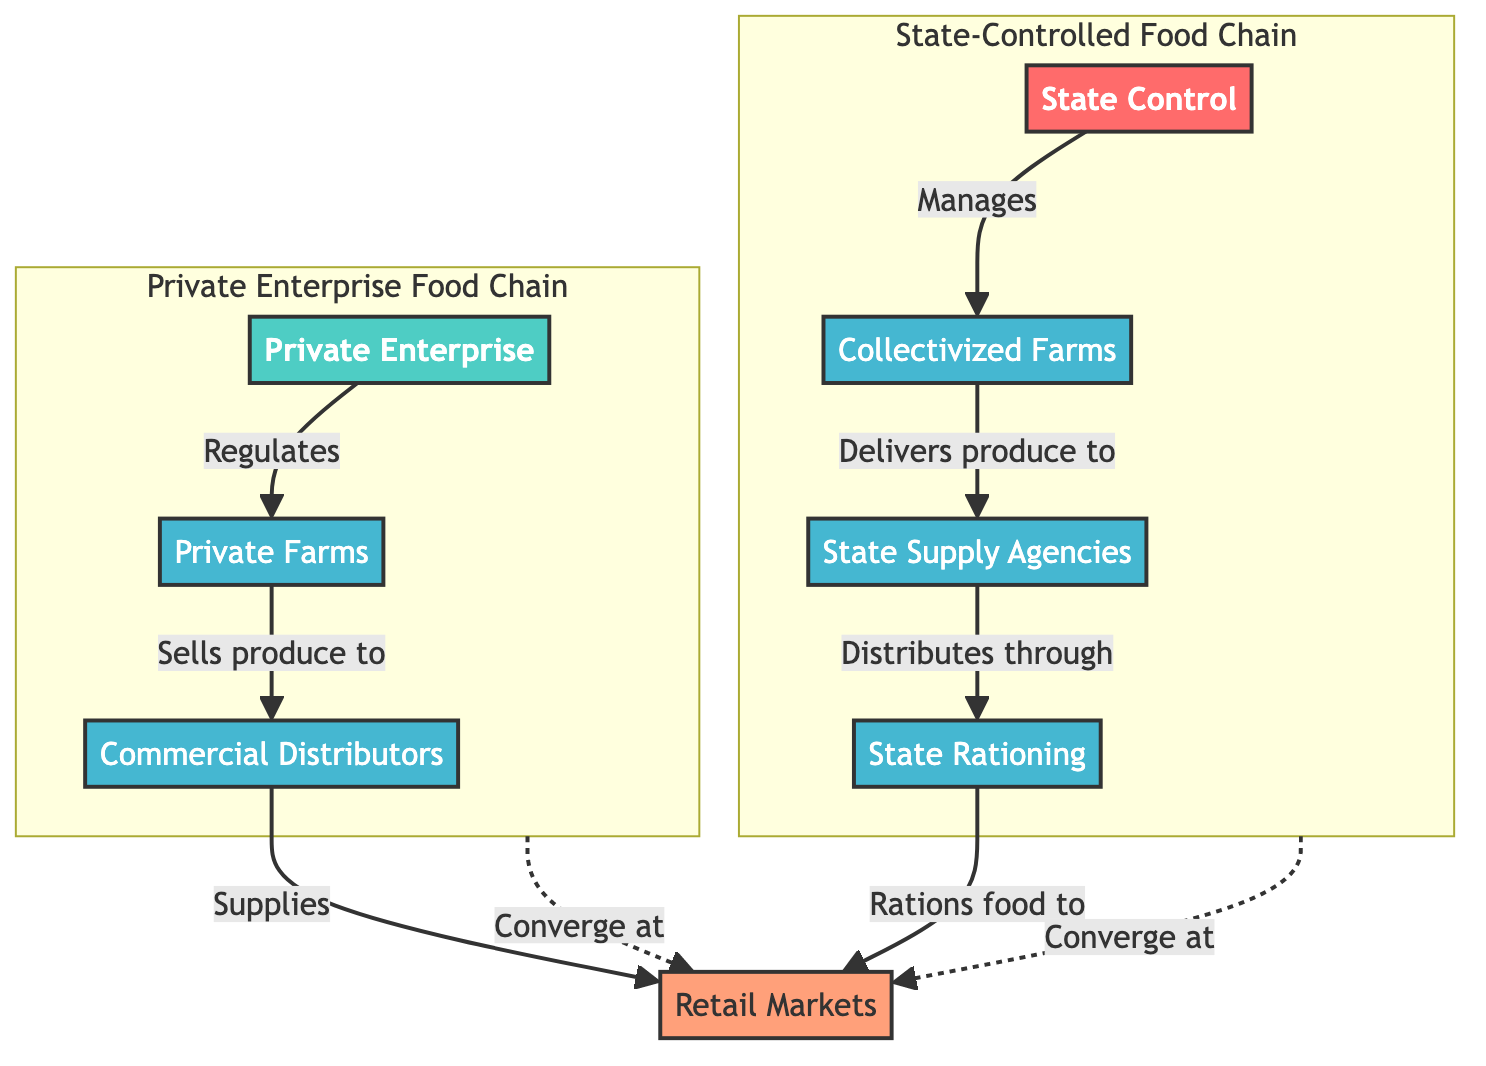What is the first node in the State-Controlled Food Chain? The first node in the State-Controlled Food Chain is "State Control", which is directly connected to collectivized farms, highlighting the authority's initial control over food production.
Answer: State Control How many nodes are in the Private Enterprise Food Chain? There are four nodes in the Private Enterprise Food Chain: Private Enterprise, Private Farms, Commercial Distributors, and the endpoint retail markets.
Answer: 4 What role does state control play in the food chain? State control manages the collectivized farms, demonstrating its dominant role in overseeing the food production process in the State-Controlled Food Chain.
Answer: Manages Which two nodes converge at retail markets? The nodes "State Rationing" from the State-Controlled Food Chain and "Commercial Distributors" from the Private Enterprise Food Chain converge at retail markets, indicating a shared endpoint for both chains.
Answer: State Rationing and Commercial Distributors What type of farms does private enterprise regulate? Private enterprise regulates "Private Farms", showing its focus on overseeing privately operated agricultural producers in the food supply structure.
Answer: Private Farms How do food products reach retail markets in the State-Controlled Food Chain? Food products reach retail markets through a sequence where collectivized farms deliver produce to state supply agencies, which then distribute through state rationing to the retail markets.
Answer: Via state rationing Which intermediary node is specific to the Private Enterprise Food Chain? The intermediary node specific to the Private Enterprise Food Chain is "Commercial Distributors," which supplies produce to retail markets in this structure.
Answer: Commercial Distributors Which node in the diagram acts as a rations distributor? The node acting as a rations distributor is "State Rationing," which is crucial in controlling the distribution of food to the retail markets in the state-controlled structure.
Answer: State Rationing 